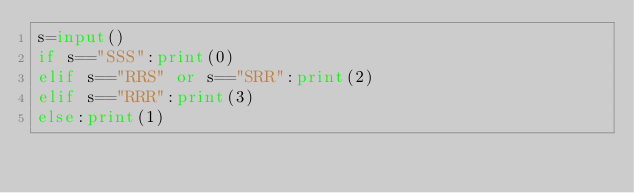Convert code to text. <code><loc_0><loc_0><loc_500><loc_500><_Python_>s=input()
if s=="SSS":print(0)
elif s=="RRS" or s=="SRR":print(2)
elif s=="RRR":print(3)
else:print(1)</code> 